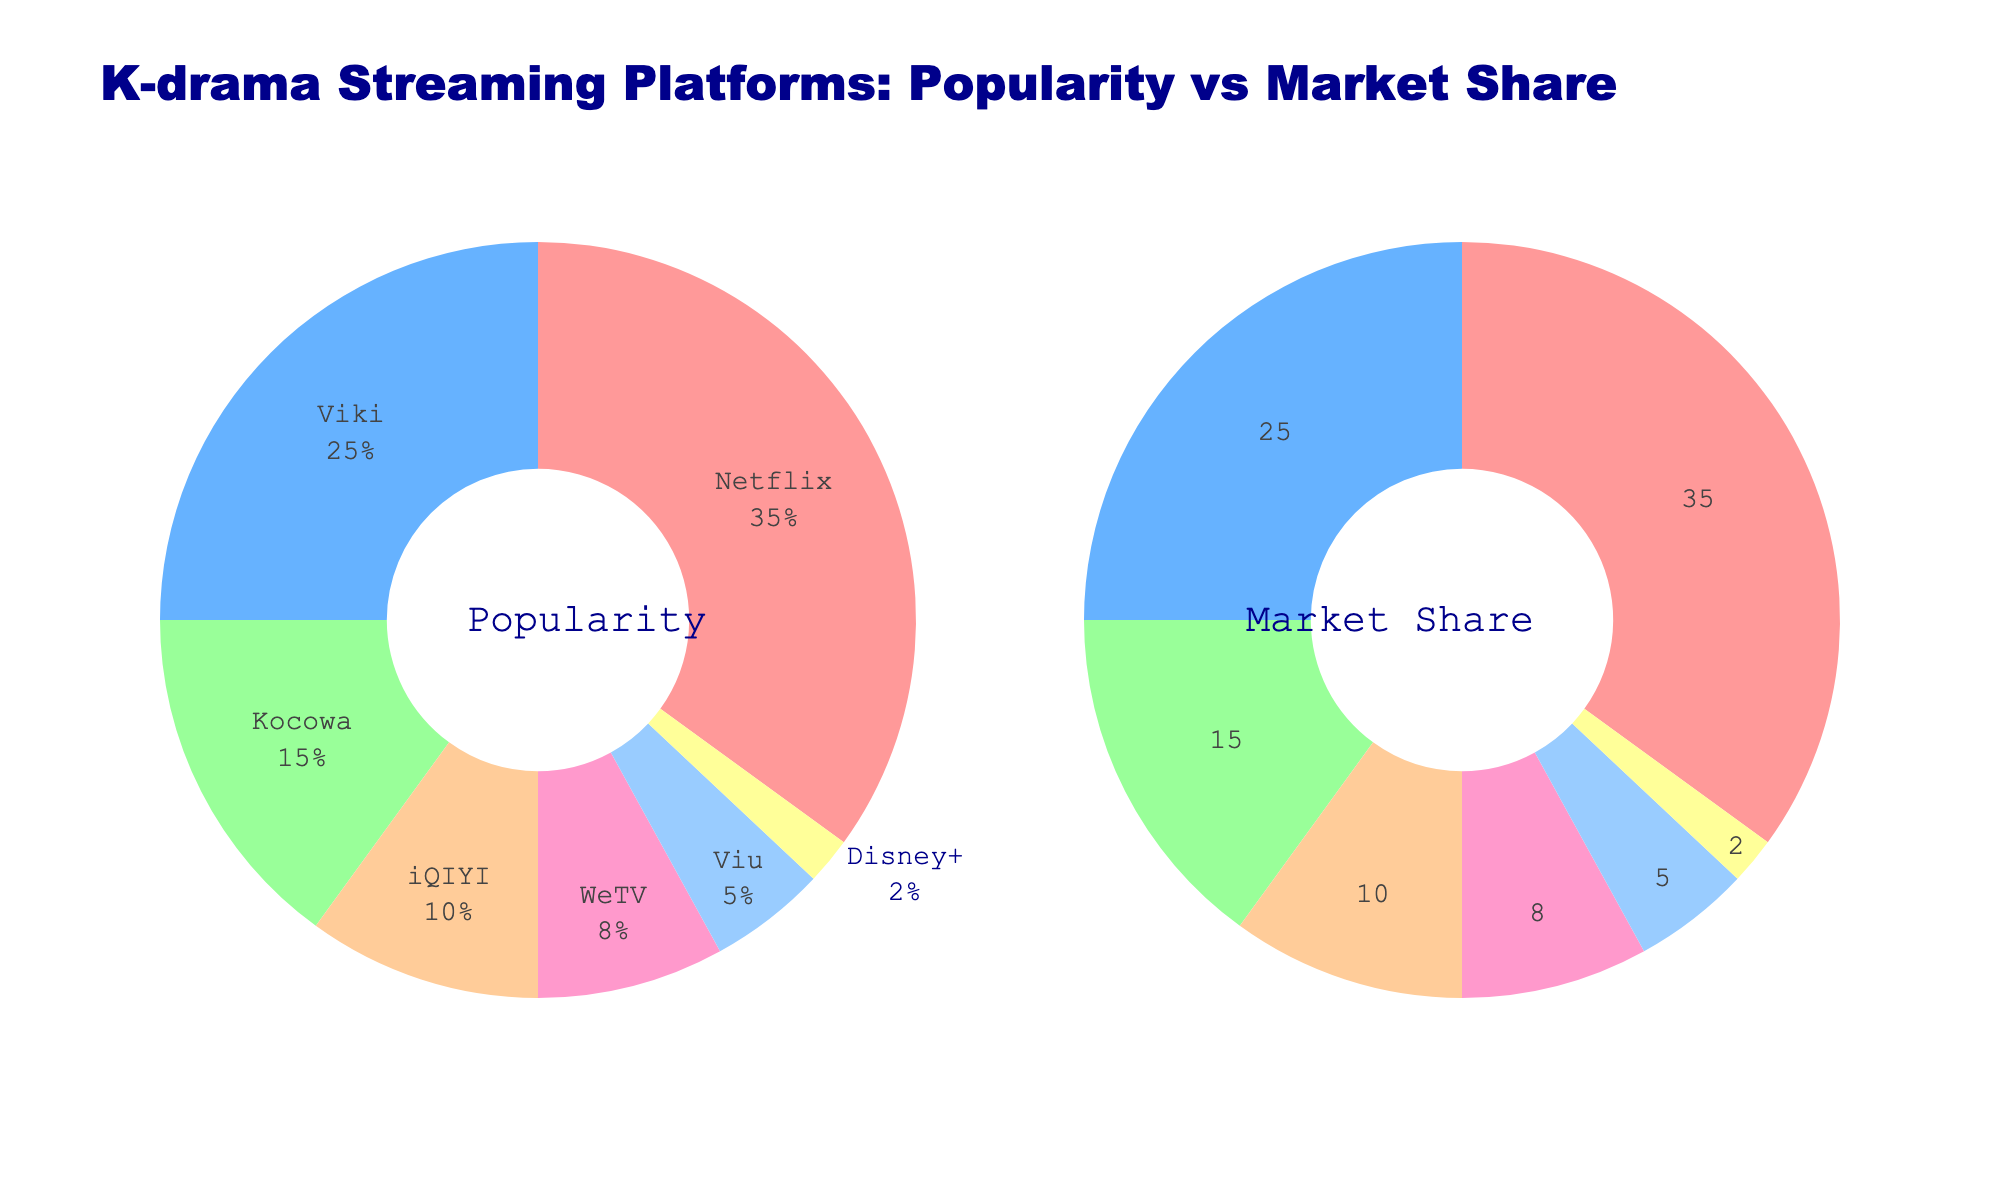what is the title of the figure? The title is displayed at the top center of the figure. It reads "K-drama Streaming Platforms: Popularity vs Market Share".
Answer: K-drama Streaming Platforms: Popularity vs Market Share Which platform has the highest percentage in both pie charts? The platform with the highest percentage can be identified by the largest segment in both pie charts. In both charts, Netflix has the largest segment.
Answer: Netflix What percentage of the market share does Disney+ have? Look at the "Market Share" pie chart and find the section labeled Disney+. The percentage value is indicated beside it.
Answer: 2% How does the popularity of WeTV compare to that of iQIYI? Locate the segments for WeTV and iQIYI in the "Popularity" pie chart to compare their percentages. WeTV has 8%, and iQIYI has 10%, so WeTV is less popular than iQIYI.
Answer: WeTV is less popular than iQIYI What is the combined popularity percentage of Viki and Kocowa? Find the popularity percentages for Viki and Kocowa in the "Popularity" pie chart, then add them together. Viki is 25% and Kocowa is 15%, thus combined is 25% + 15% = 40%.
Answer: 40% Which color represents Viu in the "Popularity" pie chart? Look for the segment labeled "Viu" in the "Popularity" pie chart and note its color. Viu is represented by a light blue color.
Answer: light blue How many platforms have a popularity percentage less than 10%? Check the "Popularity" pie chart for segments with percentages less than 10%. These platforms are iQIYI (10% not included), WeTV (8%), Viu (5%), and Disney+ (2%). Count the platforms: WeTV, Viu, and Disney+, making it three.
Answer: 3 What is the minimum market share percentage displayed? See the "Market Share" pie chart and identify the smallest percentage value displayed. The smallest percentage is for Disney+ at 2%.
Answer: 2% If you combine the market shares of Viu and Disney+, what is their total percentage? Locate the market shares for Viu and Disney+ in the "Market Share" pie chart and sum them. Viu is at 5% and Disney+ at 2%, so 5% + 2% = 7%.
Answer: 7% 